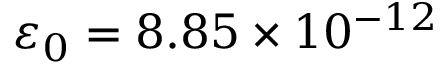Convert formula to latex. <formula><loc_0><loc_0><loc_500><loc_500>\varepsilon _ { 0 } = 8 . 8 5 \times 1 0 ^ { - 1 2 }</formula> 